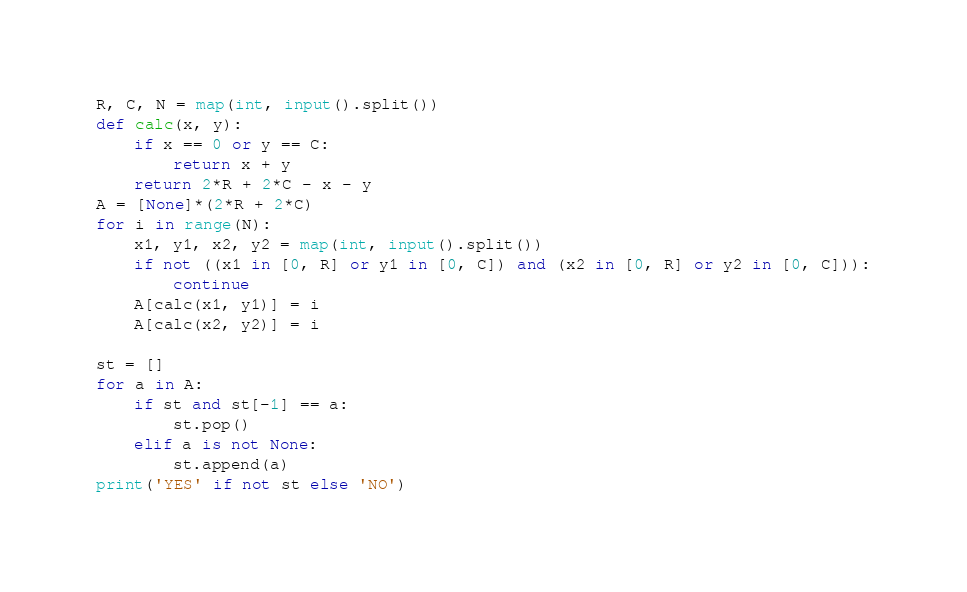<code> <loc_0><loc_0><loc_500><loc_500><_Python_>R, C, N = map(int, input().split())
def calc(x, y):
    if x == 0 or y == C:
        return x + y
    return 2*R + 2*C - x - y
A = [None]*(2*R + 2*C)
for i in range(N):
    x1, y1, x2, y2 = map(int, input().split())
    if not ((x1 in [0, R] or y1 in [0, C]) and (x2 in [0, R] or y2 in [0, C])):
        continue
    A[calc(x1, y1)] = i
    A[calc(x2, y2)] = i

st = []
for a in A:
    if st and st[-1] == a:
        st.pop()
    elif a is not None:
        st.append(a)
print('YES' if not st else 'NO')
</code> 